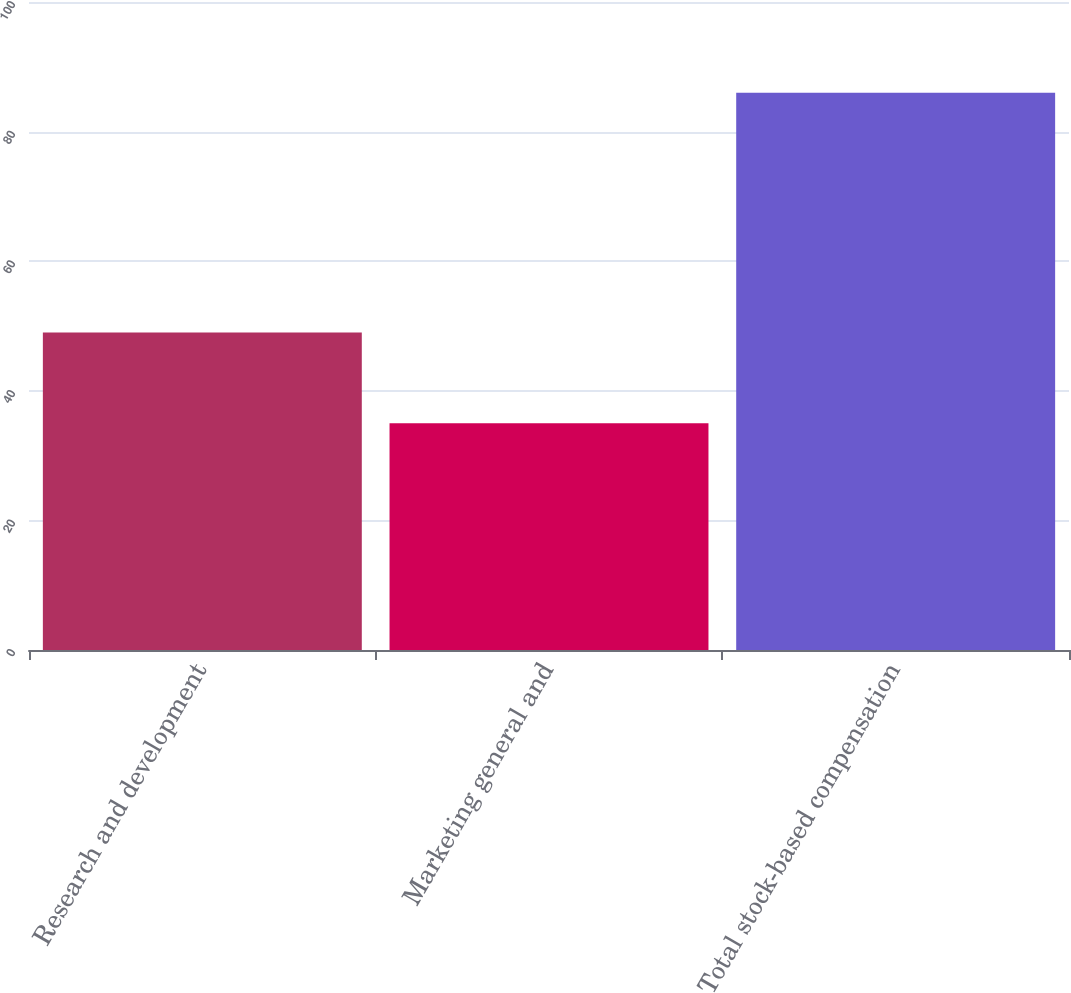Convert chart to OTSL. <chart><loc_0><loc_0><loc_500><loc_500><bar_chart><fcel>Research and development<fcel>Marketing general and<fcel>Total stock-based compensation<nl><fcel>49<fcel>35<fcel>86<nl></chart> 